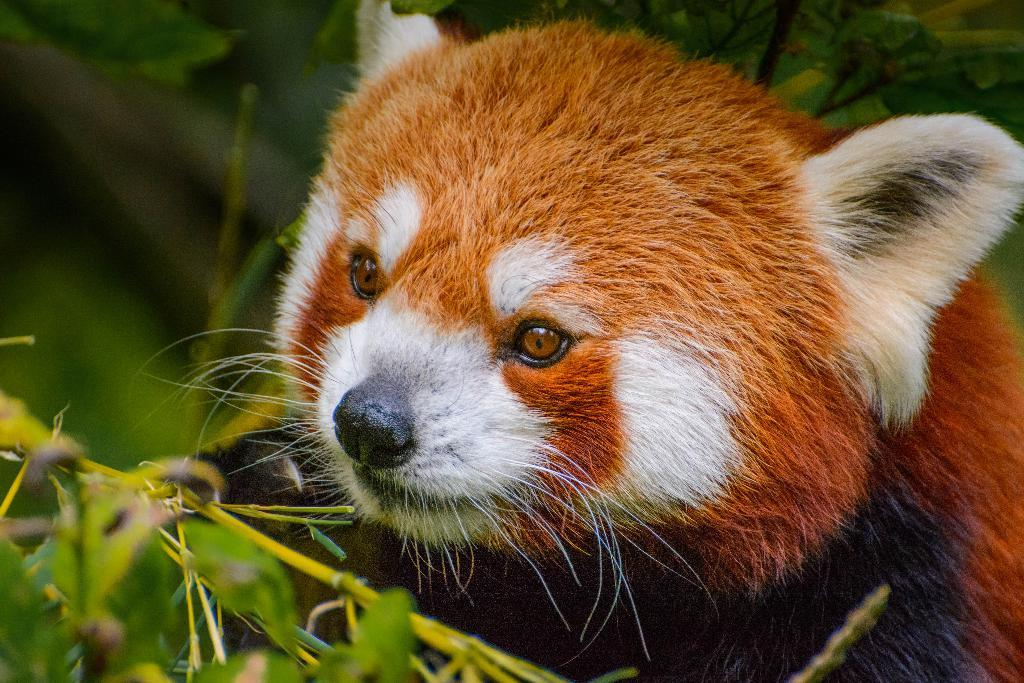What type of animal is present in the image? There is an animal in the image. What is the color of the animal? The animal is brown in color. Are there any other colors present on the animal? Yes, the animal has some white coloring. Where is the animal located in the image? The animal is near plants in the image. What is the temper of the houses in the image? There are no houses present in the image, so it is not possible to determine their temper. How does the animal interact with the system in the image? There is no system present in the image, and therefore no interaction can be observed. 